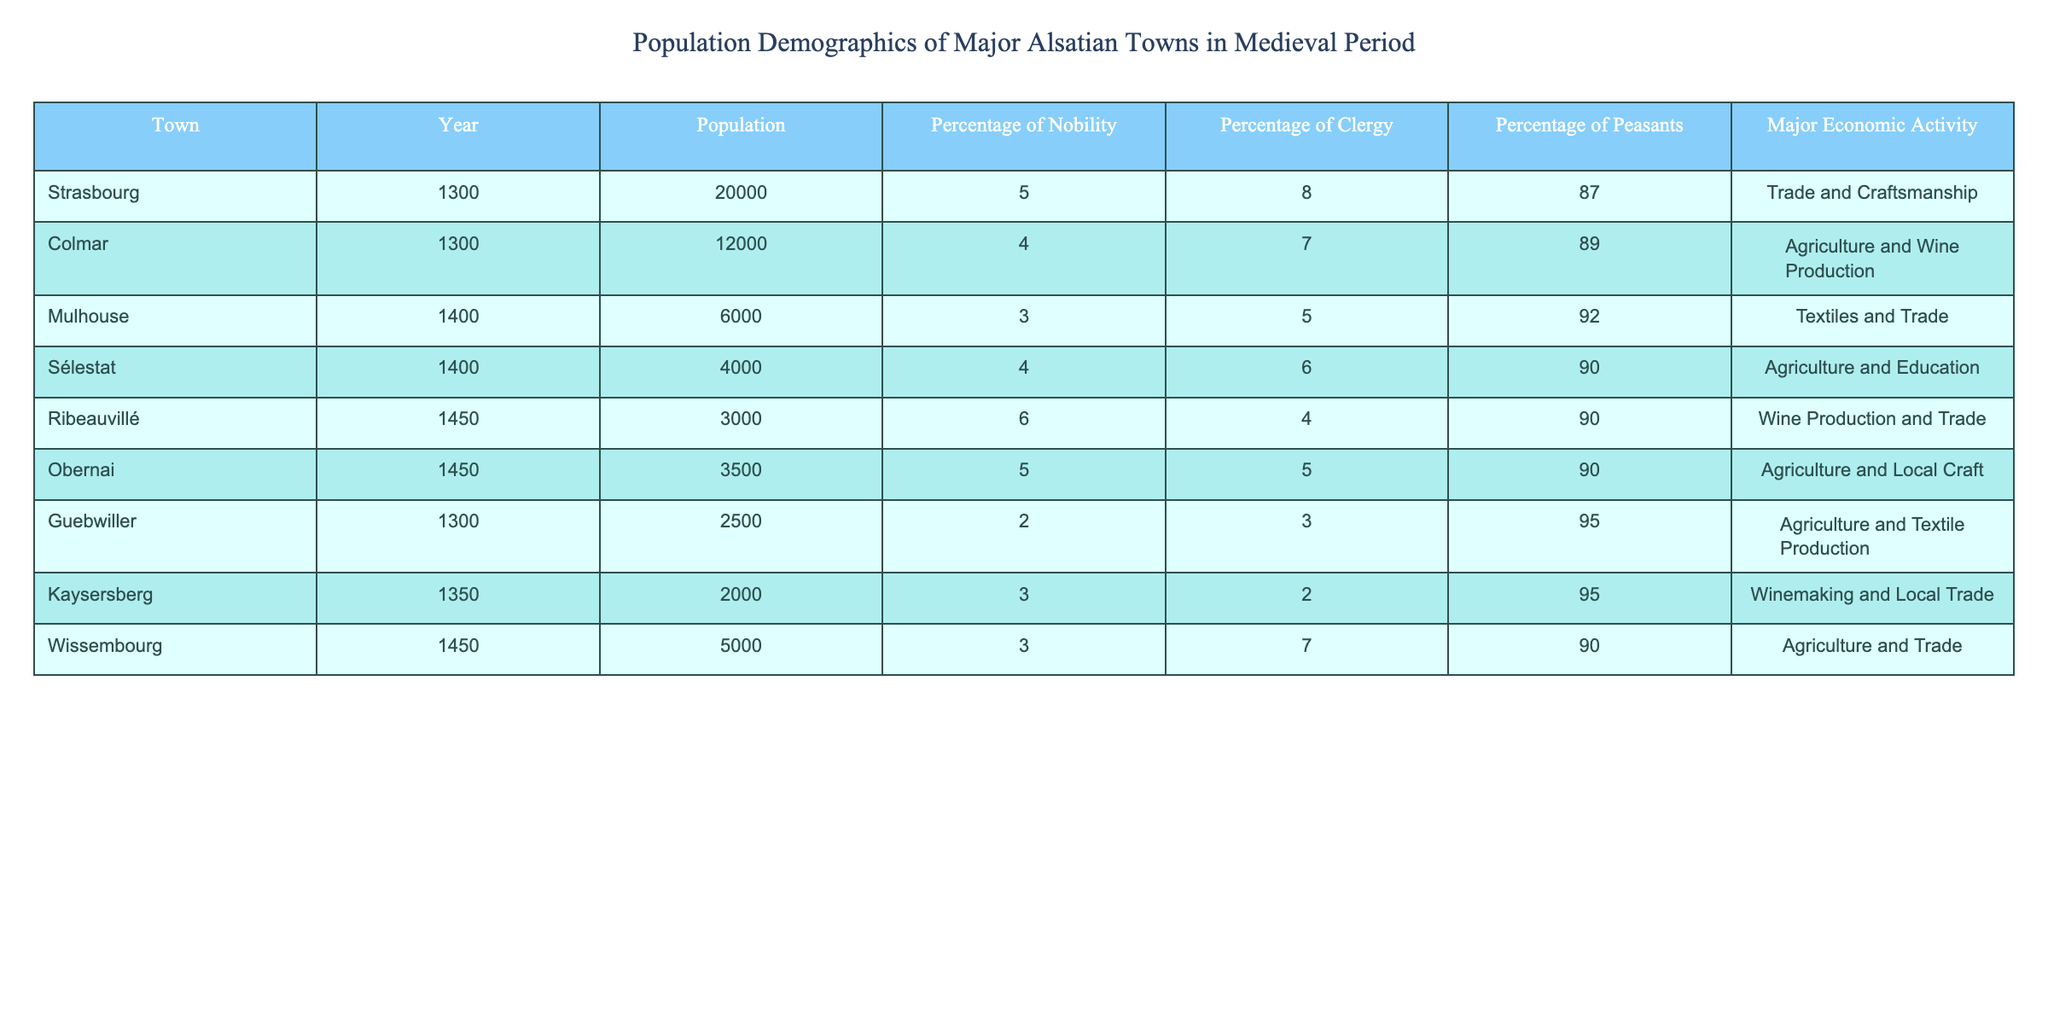What was the population of Strasbourg in 1300? According to the table, Strasbourg had a population of 20,000 in the year 1300.
Answer: 20,000 What percentage of the population in Colmar in 1300 were peasants? The table indicates that 89% of Colmar's population in 1300 were peasants.
Answer: 89% Which town had the highest percentage of nobility in 1450? Looking at the 1450 data, Ribeauvillé had a nobility percentage of 6%, which is the highest among that year's towns listed (considering the other towns have 5% or lower).
Answer: Ribeauvillé What is the average population of the towns listed for the year 1400? The populations for 1400 are Mulhouse (6000) and Sélestat (4000). Summing them gives 6000 + 4000 = 10000. Dividing by the number of towns (2) yields an average of 10000 / 2 = 5000.
Answer: 5,000 Is it true that Obernai had a higher percentage of clergy than Sélestat in 1450? Obernai had 5% clergy while Sélestat had 6% clergy, thus making the statement false.
Answer: No Which town had a major economic activity focused on textiles and trade? The table specifies that Mulhouse's major economic activity was textiles and trade.
Answer: Mulhouse What percentage of the population in Wissembourg in 1450 were peasants? The data shows that 90% of Wissembourg's population in 1450 were peasants, according to the table.
Answer: 90% Which town in 1300 had the lowest population? In 1300, Guebwiller had the lowest population with 2,500 compared to other towns listed for that year.
Answer: Guebwiller What was the difference in population between Strasbourg in 1300 and Mulhouse in 1400? The population of Strasbourg in 1300 was 20,000 and that of Mulhouse in 1400 was 6,000. The difference is 20,000 - 6,000 = 14,000.
Answer: 14,000 